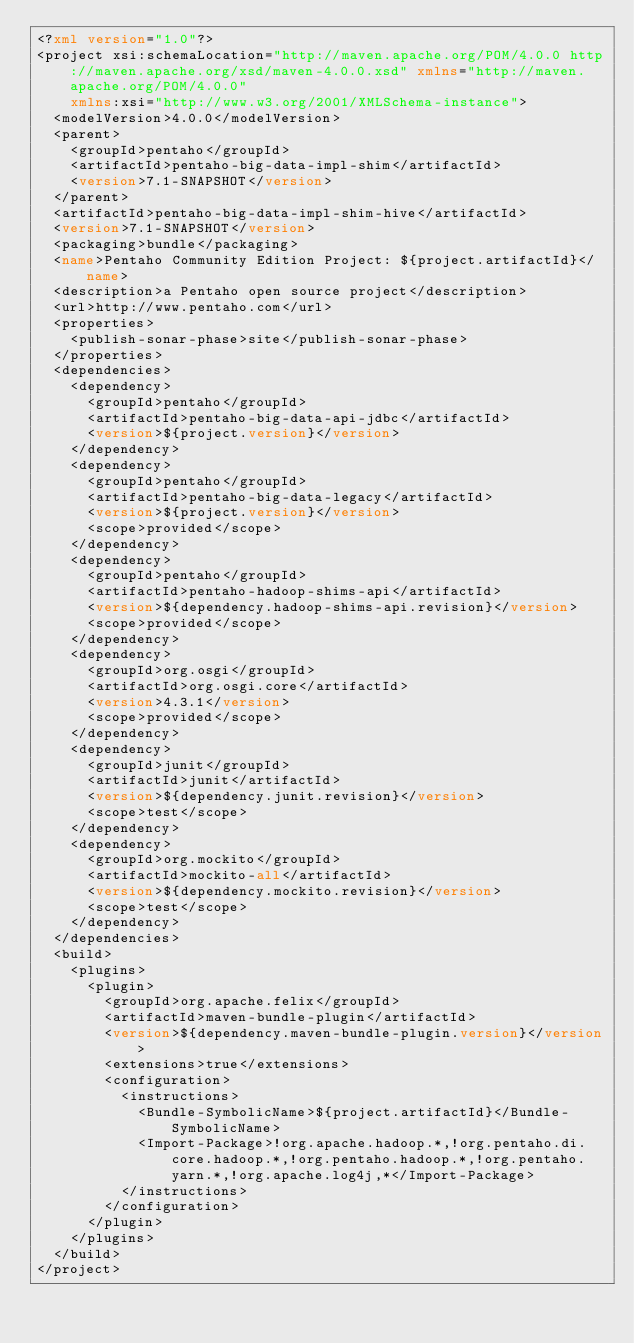Convert code to text. <code><loc_0><loc_0><loc_500><loc_500><_XML_><?xml version="1.0"?>
<project xsi:schemaLocation="http://maven.apache.org/POM/4.0.0 http://maven.apache.org/xsd/maven-4.0.0.xsd" xmlns="http://maven.apache.org/POM/4.0.0"
    xmlns:xsi="http://www.w3.org/2001/XMLSchema-instance">
  <modelVersion>4.0.0</modelVersion>
  <parent>
    <groupId>pentaho</groupId>
    <artifactId>pentaho-big-data-impl-shim</artifactId>
    <version>7.1-SNAPSHOT</version>
  </parent>
  <artifactId>pentaho-big-data-impl-shim-hive</artifactId>
  <version>7.1-SNAPSHOT</version>
  <packaging>bundle</packaging>
  <name>Pentaho Community Edition Project: ${project.artifactId}</name>
  <description>a Pentaho open source project</description>
  <url>http://www.pentaho.com</url>
  <properties>
    <publish-sonar-phase>site</publish-sonar-phase>
  </properties>
  <dependencies>
    <dependency>
      <groupId>pentaho</groupId>
      <artifactId>pentaho-big-data-api-jdbc</artifactId>
      <version>${project.version}</version>
    </dependency>
    <dependency>
      <groupId>pentaho</groupId>
      <artifactId>pentaho-big-data-legacy</artifactId>
      <version>${project.version}</version>
      <scope>provided</scope>
    </dependency>
    <dependency>
      <groupId>pentaho</groupId>
      <artifactId>pentaho-hadoop-shims-api</artifactId>
      <version>${dependency.hadoop-shims-api.revision}</version>
      <scope>provided</scope>
    </dependency>
    <dependency>
      <groupId>org.osgi</groupId>
      <artifactId>org.osgi.core</artifactId>
      <version>4.3.1</version>
      <scope>provided</scope>
    </dependency>
    <dependency>
      <groupId>junit</groupId>
      <artifactId>junit</artifactId>
      <version>${dependency.junit.revision}</version>
      <scope>test</scope>
    </dependency>
    <dependency>
      <groupId>org.mockito</groupId>
      <artifactId>mockito-all</artifactId>
      <version>${dependency.mockito.revision}</version>
      <scope>test</scope>
    </dependency>
  </dependencies>
  <build>
    <plugins>
      <plugin>
        <groupId>org.apache.felix</groupId>
        <artifactId>maven-bundle-plugin</artifactId>
        <version>${dependency.maven-bundle-plugin.version}</version>
        <extensions>true</extensions>
        <configuration>
          <instructions>
            <Bundle-SymbolicName>${project.artifactId}</Bundle-SymbolicName>
            <Import-Package>!org.apache.hadoop.*,!org.pentaho.di.core.hadoop.*,!org.pentaho.hadoop.*,!org.pentaho.yarn.*,!org.apache.log4j,*</Import-Package>
          </instructions>
        </configuration>
      </plugin>
    </plugins>
  </build>
</project>
</code> 